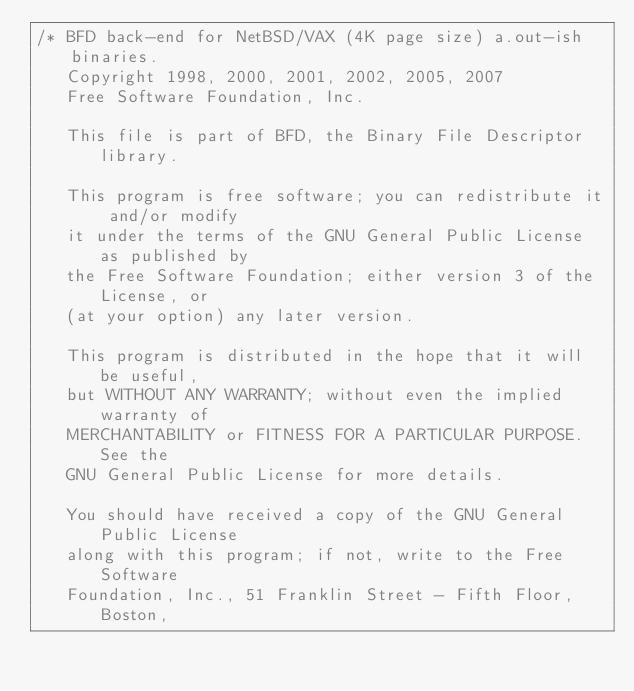<code> <loc_0><loc_0><loc_500><loc_500><_C_>/* BFD back-end for NetBSD/VAX (4K page size) a.out-ish binaries.
   Copyright 1998, 2000, 2001, 2002, 2005, 2007
   Free Software Foundation, Inc.

   This file is part of BFD, the Binary File Descriptor library.

   This program is free software; you can redistribute it and/or modify
   it under the terms of the GNU General Public License as published by
   the Free Software Foundation; either version 3 of the License, or
   (at your option) any later version.

   This program is distributed in the hope that it will be useful,
   but WITHOUT ANY WARRANTY; without even the implied warranty of
   MERCHANTABILITY or FITNESS FOR A PARTICULAR PURPOSE.  See the
   GNU General Public License for more details.

   You should have received a copy of the GNU General Public License
   along with this program; if not, write to the Free Software
   Foundation, Inc., 51 Franklin Street - Fifth Floor, Boston,</code> 